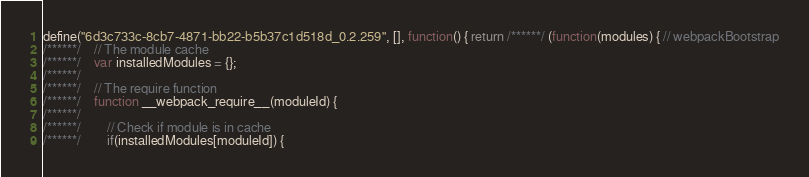<code> <loc_0><loc_0><loc_500><loc_500><_JavaScript_>define("6d3c733c-8cb7-4871-bb22-b5b37c1d518d_0.2.259", [], function() { return /******/ (function(modules) { // webpackBootstrap
/******/ 	// The module cache
/******/ 	var installedModules = {};
/******/
/******/ 	// The require function
/******/ 	function __webpack_require__(moduleId) {
/******/
/******/ 		// Check if module is in cache
/******/ 		if(installedModules[moduleId]) {</code> 